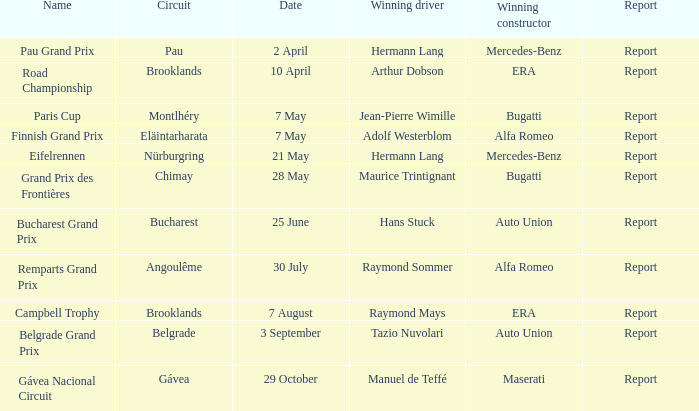Provide the summary for 30 july. Report. 